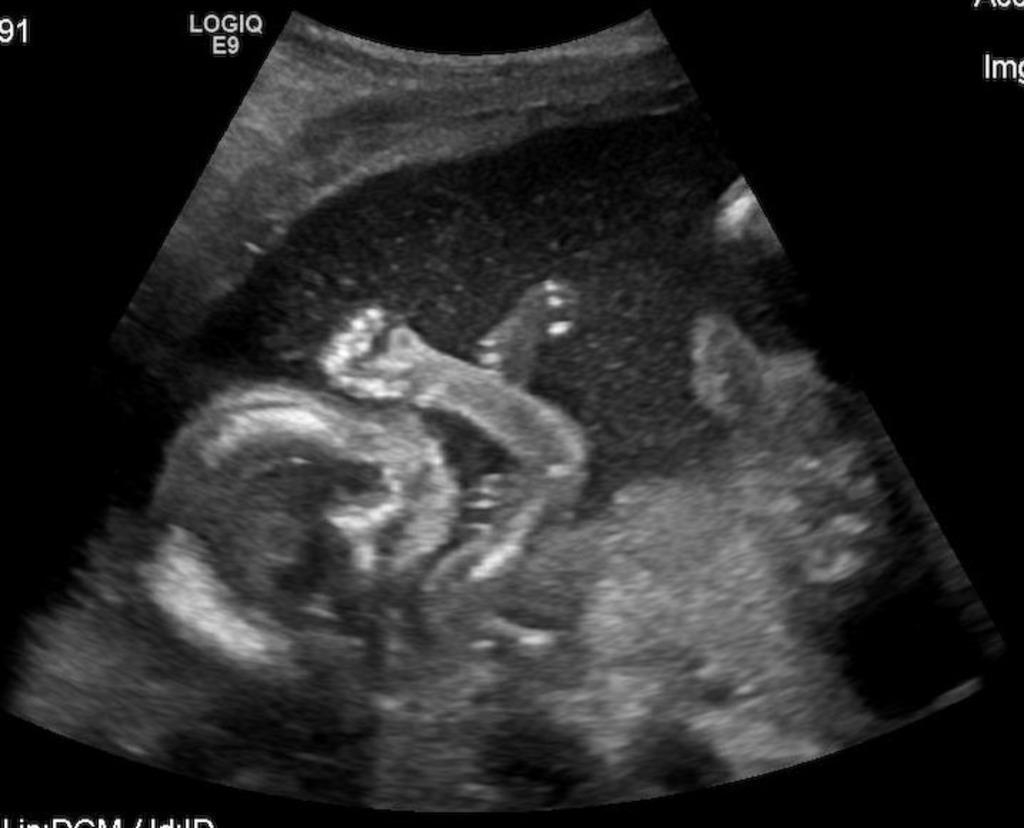In one or two sentences, can you explain what this image depicts? This image consists of scanning report. It seems to be a display. And we can see a kid. 